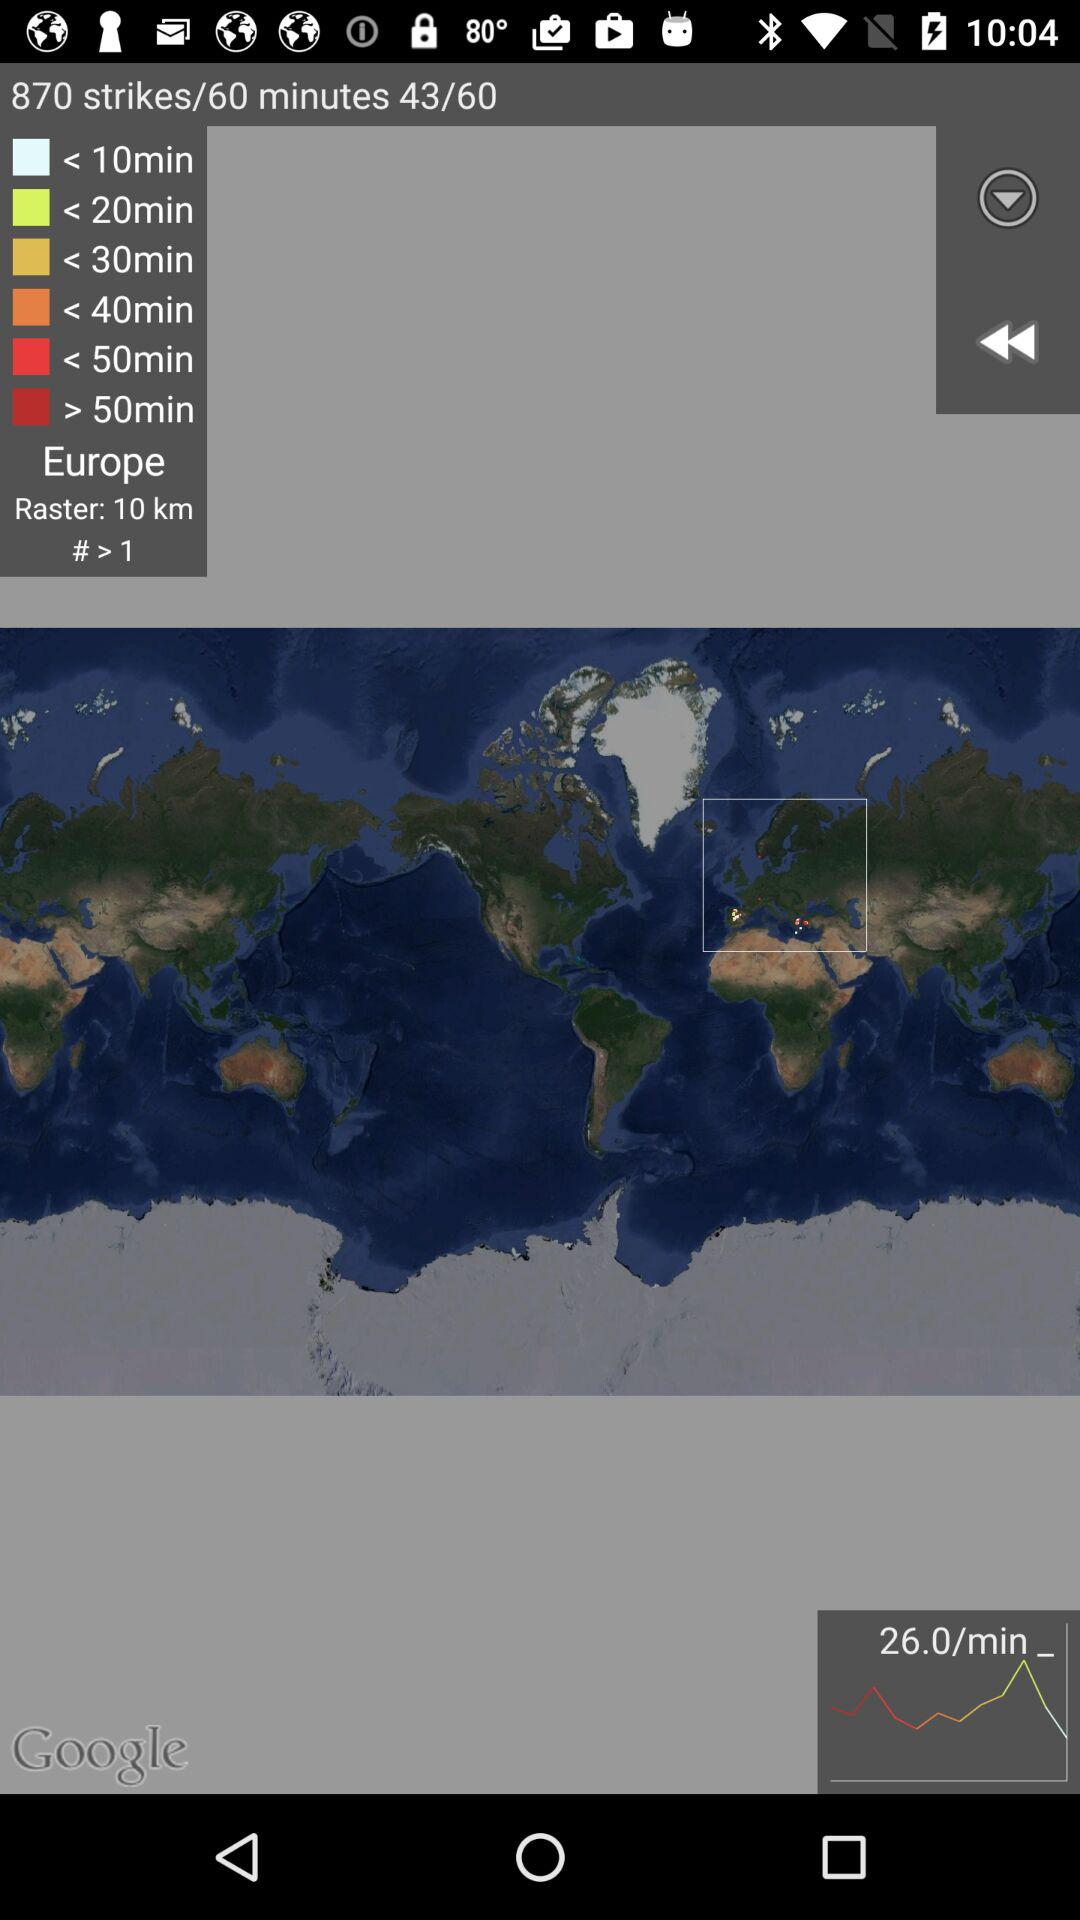How many strikes are there? There are 870 strikes. 